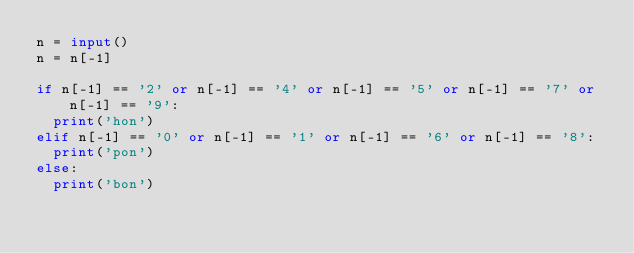Convert code to text. <code><loc_0><loc_0><loc_500><loc_500><_Python_>n = input()
n = n[-1]

if n[-1] == '2' or n[-1] == '4' or n[-1] == '5' or n[-1] == '7' or n[-1] == '9':
  print('hon')
elif n[-1] == '0' or n[-1] == '1' or n[-1] == '6' or n[-1] == '8':
  print('pon')
else:
  print('bon')</code> 